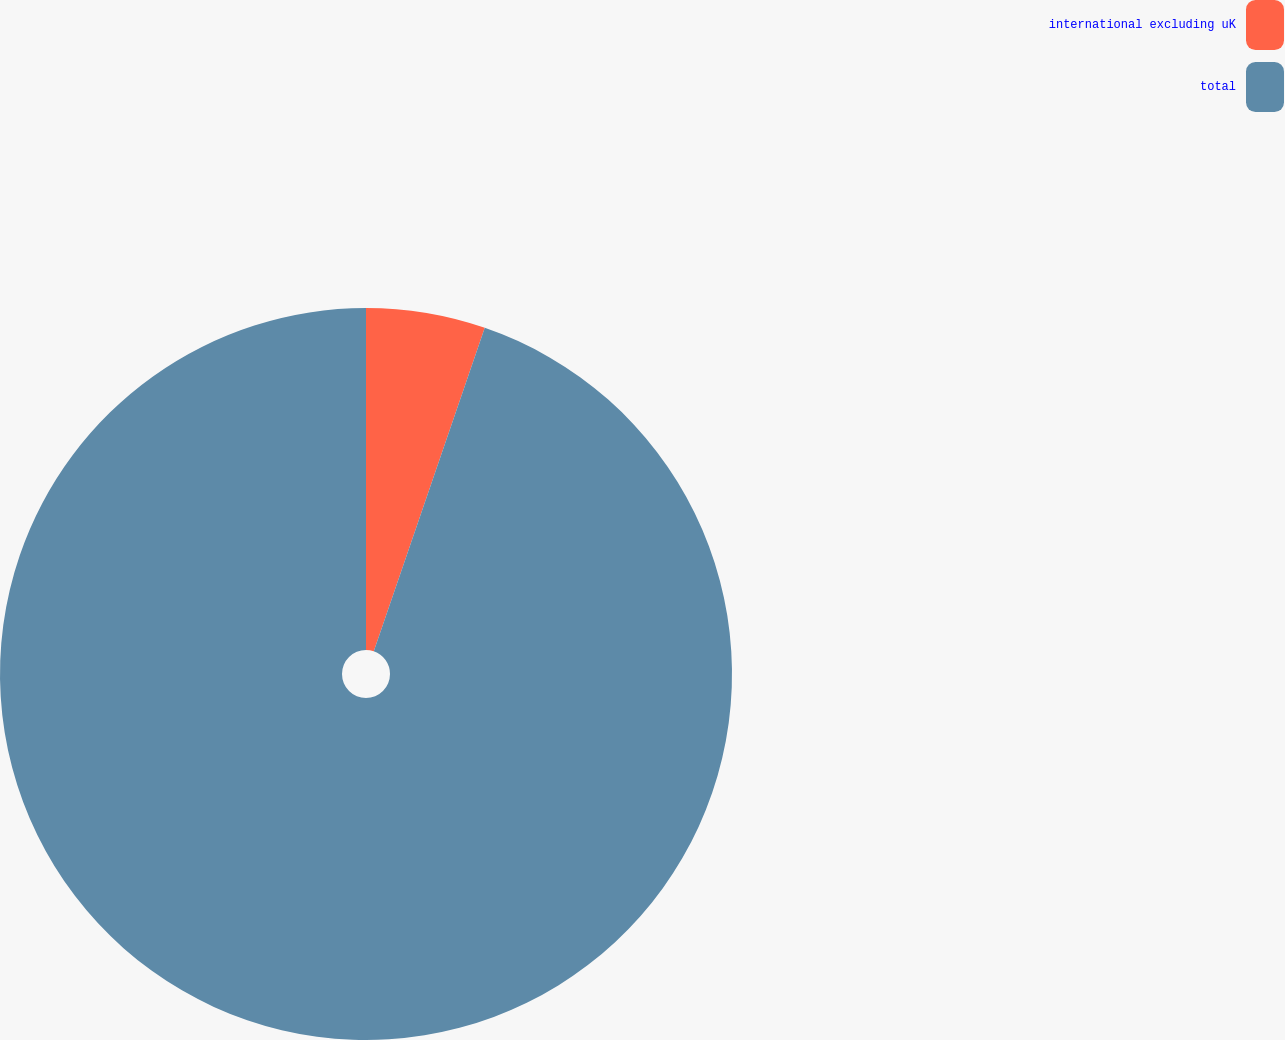Convert chart. <chart><loc_0><loc_0><loc_500><loc_500><pie_chart><fcel>international excluding uK<fcel>total<nl><fcel>5.26%<fcel>94.74%<nl></chart> 